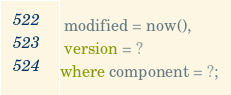Convert code to text. <code><loc_0><loc_0><loc_500><loc_500><_SQL_> modified = now(),
 version = ?
where component = ?;</code> 